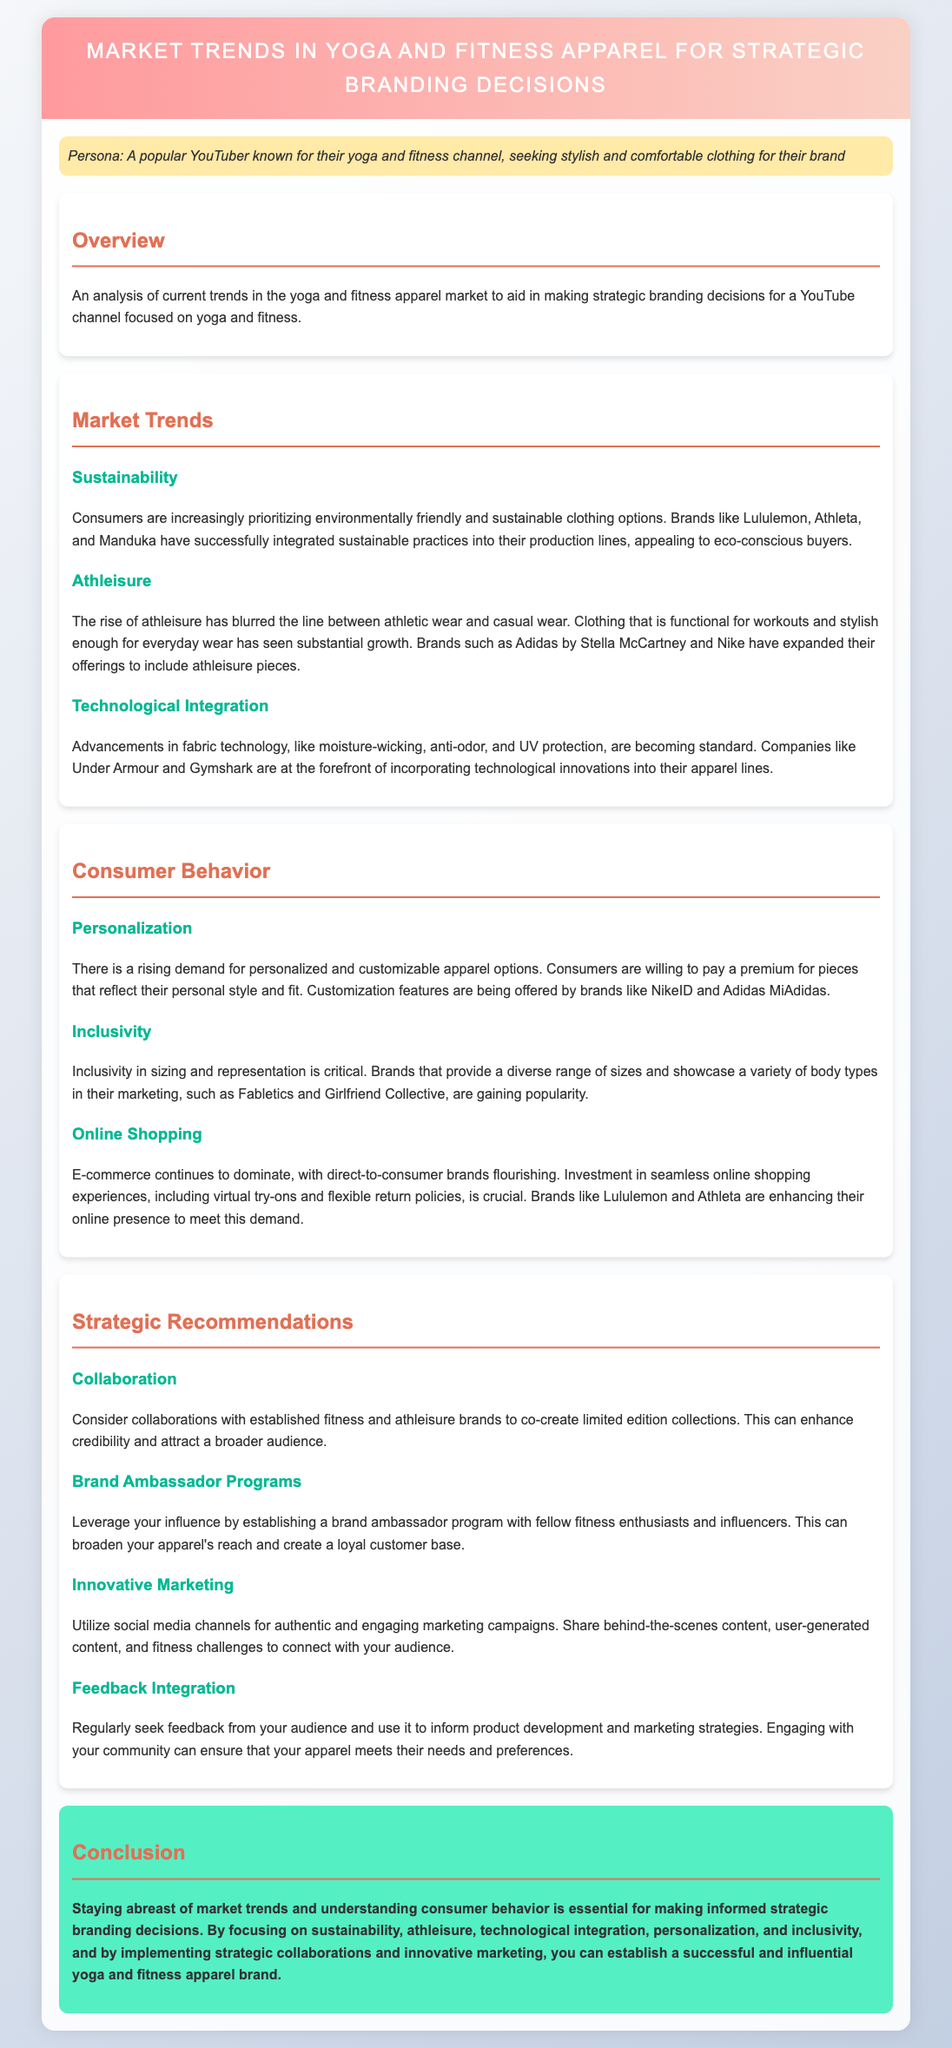what is the main focus of the document? The main focus is on analyzing market trends in yoga and fitness apparel to aid strategic branding decisions for a YouTube channel.
Answer: market trends in yoga and fitness apparel which brand is mentioned as integrating sustainable practices? Lululemon is part of the brands that have successfully integrated sustainable practices into their production lines.
Answer: Lululemon what has contributed to the growth of athleisure? The growth of athleisure has been contributed to by the blurring line between athletic wear and casual wear.
Answer: blurring line between athletic wear and casual wear which technology feature is becoming standard in fitness apparel? Advancements in fabric technology, such as moisture-wicking, anti-odor, and UV protection, are becoming standard.
Answer: moisture-wicking, anti-odor, UV protection what type of apparel customization is popular among consumers? There is a rising demand for personalized and customizable apparel options.
Answer: personalized and customizable apparel options how can a YouTuber enhance credibility through collaborations? Collaborations with established fitness and athleisure brands can enhance credibility.
Answer: collaborations with established fitness and athleisure brands what is emphasized as crucial for e-commerce brands? Investment in seamless online shopping experiences is emphasized as crucial for e-commerce brands.
Answer: seamless online shopping experiences which social media strategy is recommended for marketing? Utilizing social media channels for authentic and engaging marketing campaigns is recommended.
Answer: authentic and engaging marketing campaigns what aspect of consumer behavior is critical according to the document? Inclusivity in sizing and representation is critical according to the document.
Answer: Inclusivity in sizing and representation 